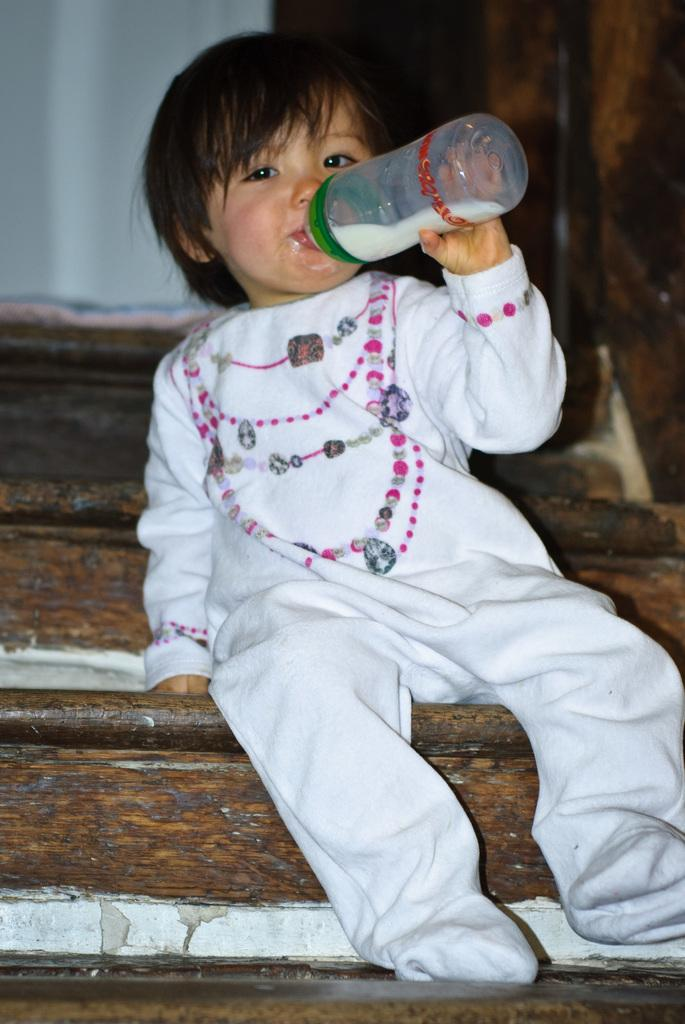What is the main subject of the image? The main subject of the image is a kid. Where is the kid located in the image? The kid is sitting on steps. What is the kid holding in the image? The kid is holding a bottle. What is the kid doing with the bottle? The kid is drinking from the bottle. What type of star can be seen in the image? There is no star visible in the image. Is there a dog present in the image? No, there is no dog present in the image. 